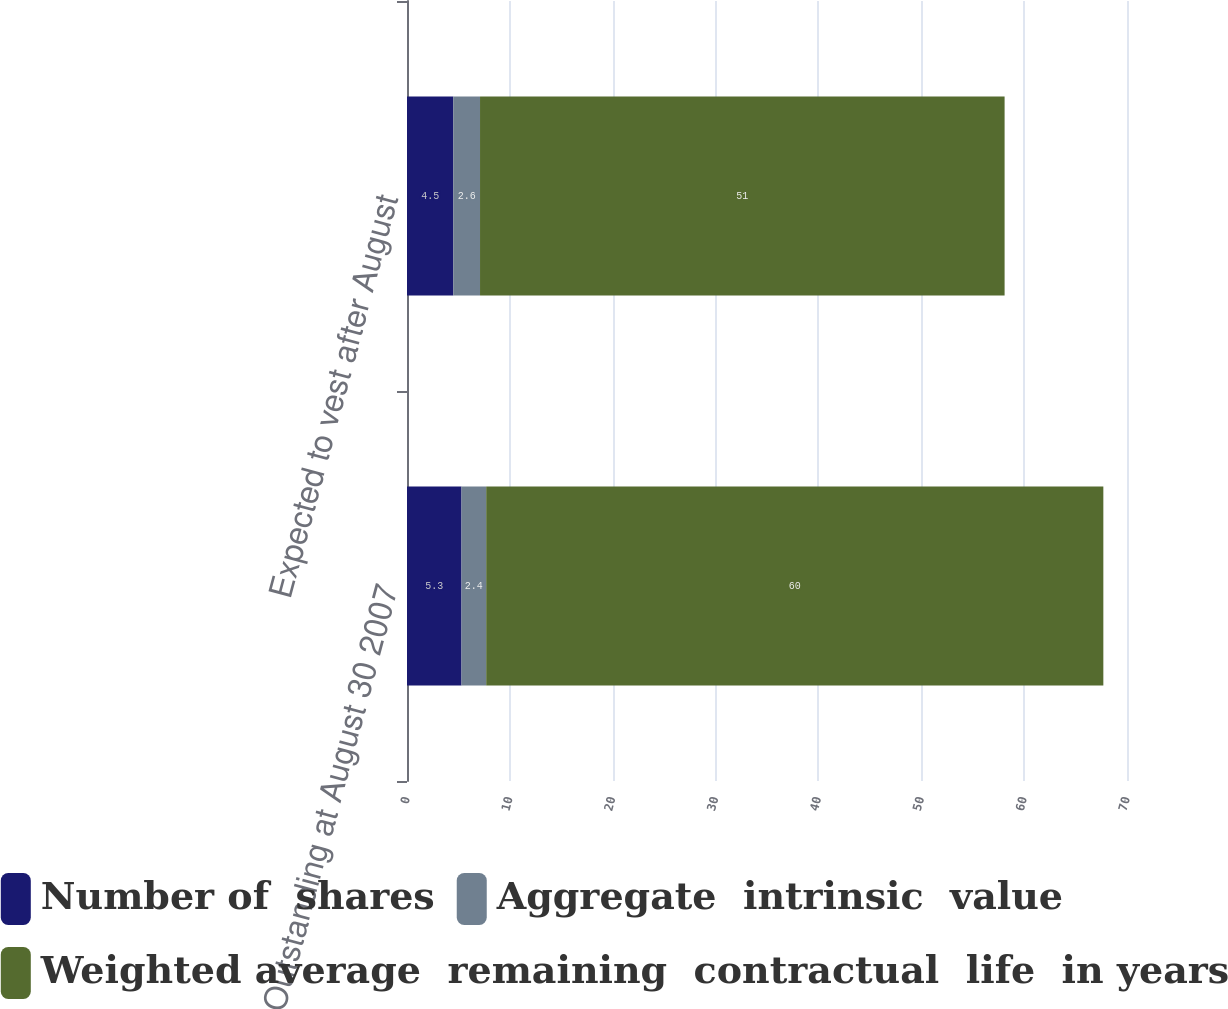Convert chart. <chart><loc_0><loc_0><loc_500><loc_500><stacked_bar_chart><ecel><fcel>Outstanding at August 30 2007<fcel>Expected to vest after August<nl><fcel>Number of  shares<fcel>5.3<fcel>4.5<nl><fcel>Aggregate  intrinsic  value<fcel>2.4<fcel>2.6<nl><fcel>Weighted average  remaining  contractual  life  in years<fcel>60<fcel>51<nl></chart> 